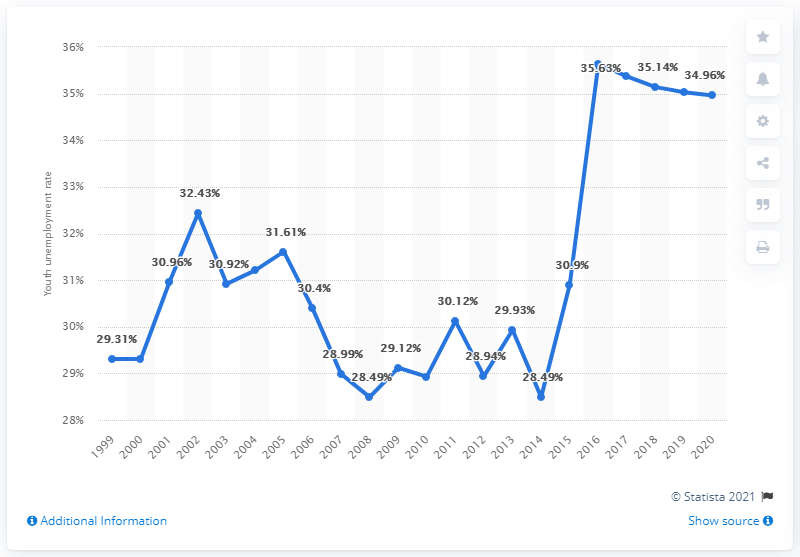Identify some key points in this picture. In 2020, the youth unemployment rate in Jordan was 34.96%. 